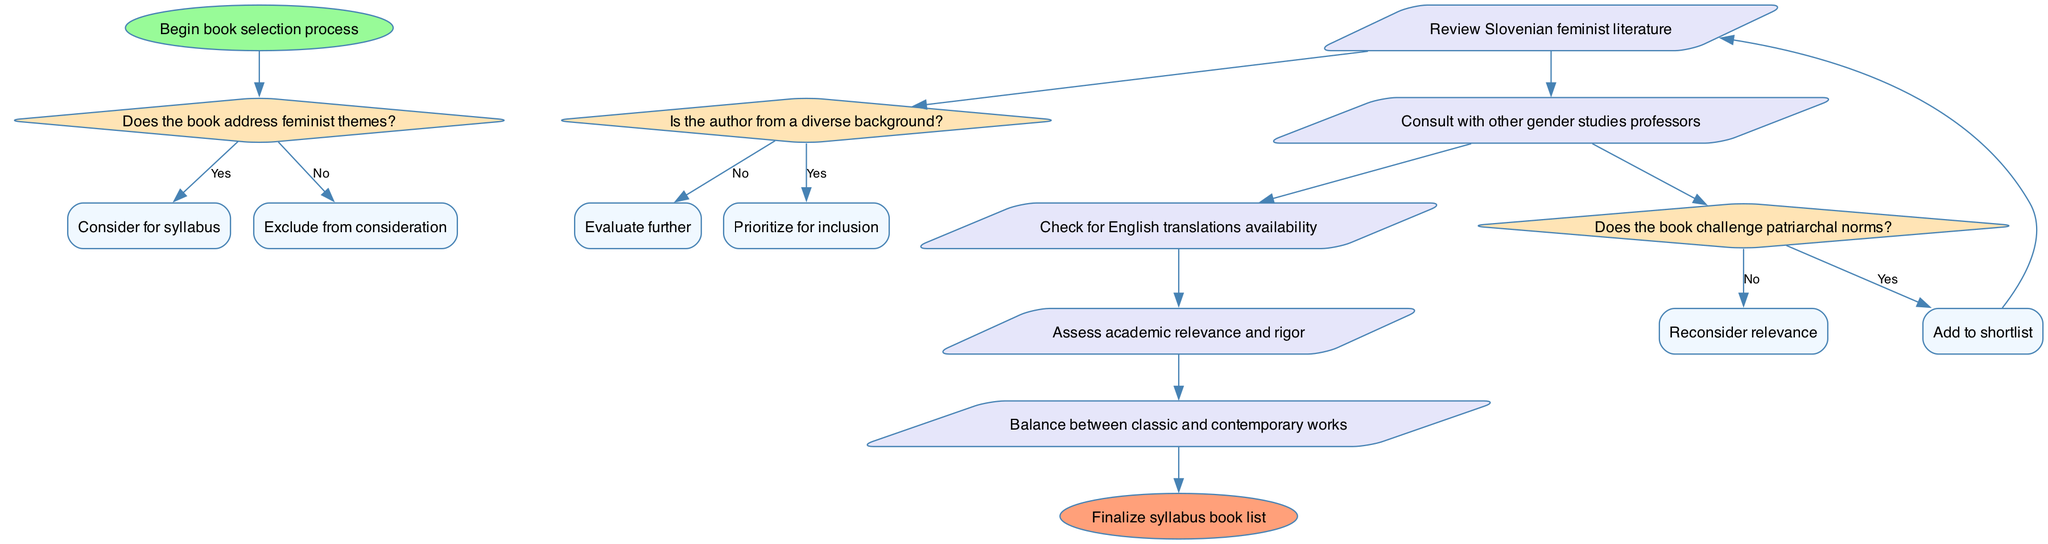What is the starting point of the book selection process? The flowchart begins with the node labeled "Begin book selection process". This node indicates the initiation of the decision-making sequence.
Answer: Begin book selection process How many decision nodes are present in the diagram? There are three decision nodes in the diagram, corresponding to questions about feminist themes, author diversity, and challenging patriarchal norms.
Answer: 3 What is the action following the decision about an author's diverse background if the answer is yes? The action that follows a 'yes' answer to the question about the author's diverse background is "Prioritize for inclusion". This indicates that the book is prioritized for the syllabus.
Answer: Prioritize for inclusion Which node leads to the action of reviewing Slovenian feminist literature? The action of reviewing Slovenian feminist literature is accessed after a successful path through the decision nodes, particularly if the decisions about feminist themes and other relevant factors yield affirmative responses. Specifically, it arises after the decision to consider the book due to relevant themes.
Answer: Review Slovenian feminist literature If a book does not challenge patriarchal norms, what should be done according to the flowchart? If a book does not challenge patriarchal norms, the flowchart states to "Reconsider relevance". This means the book’s significance for inclusion in the syllabus is questioned, and its value needs further evaluation.
Answer: Reconsider relevance 